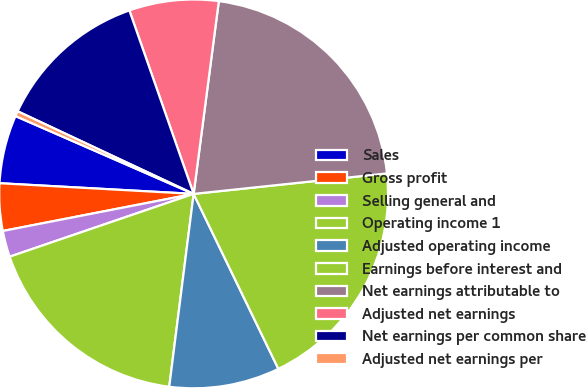Convert chart to OTSL. <chart><loc_0><loc_0><loc_500><loc_500><pie_chart><fcel>Sales<fcel>Gross profit<fcel>Selling general and<fcel>Operating income 1<fcel>Adjusted operating income<fcel>Earnings before interest and<fcel>Net earnings attributable to<fcel>Adjusted net earnings<fcel>Net earnings per common share<fcel>Adjusted net earnings per<nl><fcel>5.68%<fcel>3.93%<fcel>2.18%<fcel>17.76%<fcel>9.18%<fcel>19.5%<fcel>21.25%<fcel>7.43%<fcel>12.65%<fcel>0.43%<nl></chart> 